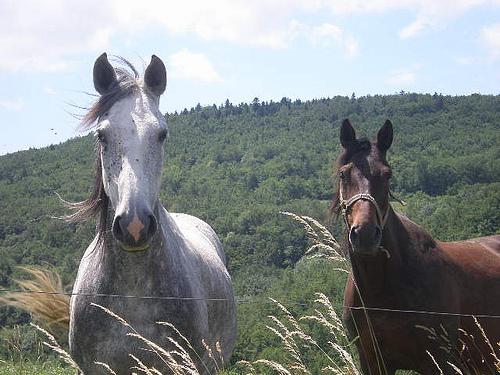Which way is the wind blowing?
Short answer required. Left. What color is the horse on the left?
Write a very short answer. White. How many of the animals are wearing bridles?
Short answer required. 1. 